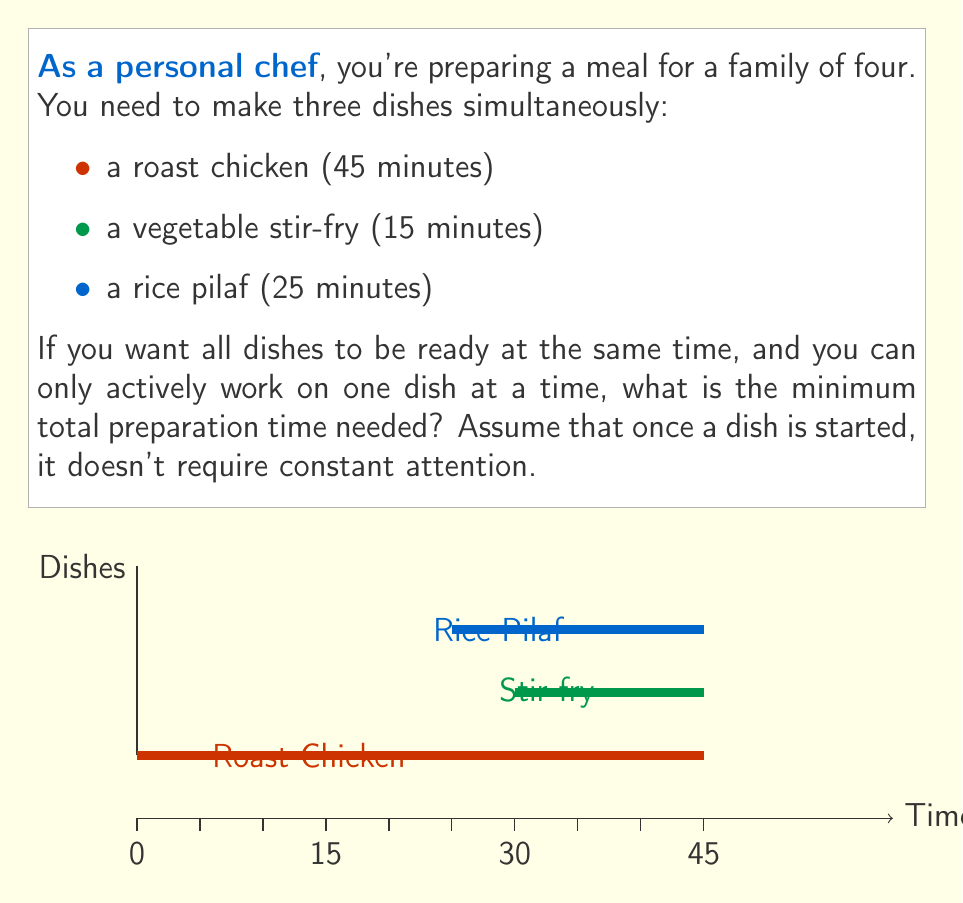Solve this math problem. Let's approach this step-by-step:

1) First, we need to identify the dish that takes the longest time to cook. In this case, it's the roast chicken at 45 minutes.

2) We want all dishes to finish at the same time, so we'll work backwards from the 45-minute mark:

   $$45 - 15 = 30$$ minutes before the end for the stir-fry
   $$45 - 25 = 20$$ minutes before the end for the rice pilaf

3) Now, let's consider the sequence of actions:
   - Start the roast chicken (takes no prep time in this scenario)
   - At the 20-minute mark, start the rice pilaf
   - At the 30-minute mark, start the vegetable stir-fry

4) The question asks for the minimum total preparation time. This would be the time you spend actively preparing dishes:
   - Time to start chicken: 0 minutes (assumed)
   - Time to prepare rice pilaf: 5 minutes (25 - 20)
   - Time to prepare stir-fry: 5 minutes (35 - 30)

5) Total active preparation time:
   $$0 + 5 + 5 = 10$$ minutes

Therefore, the minimum total preparation time needed is 10 minutes.
Answer: 10 minutes 